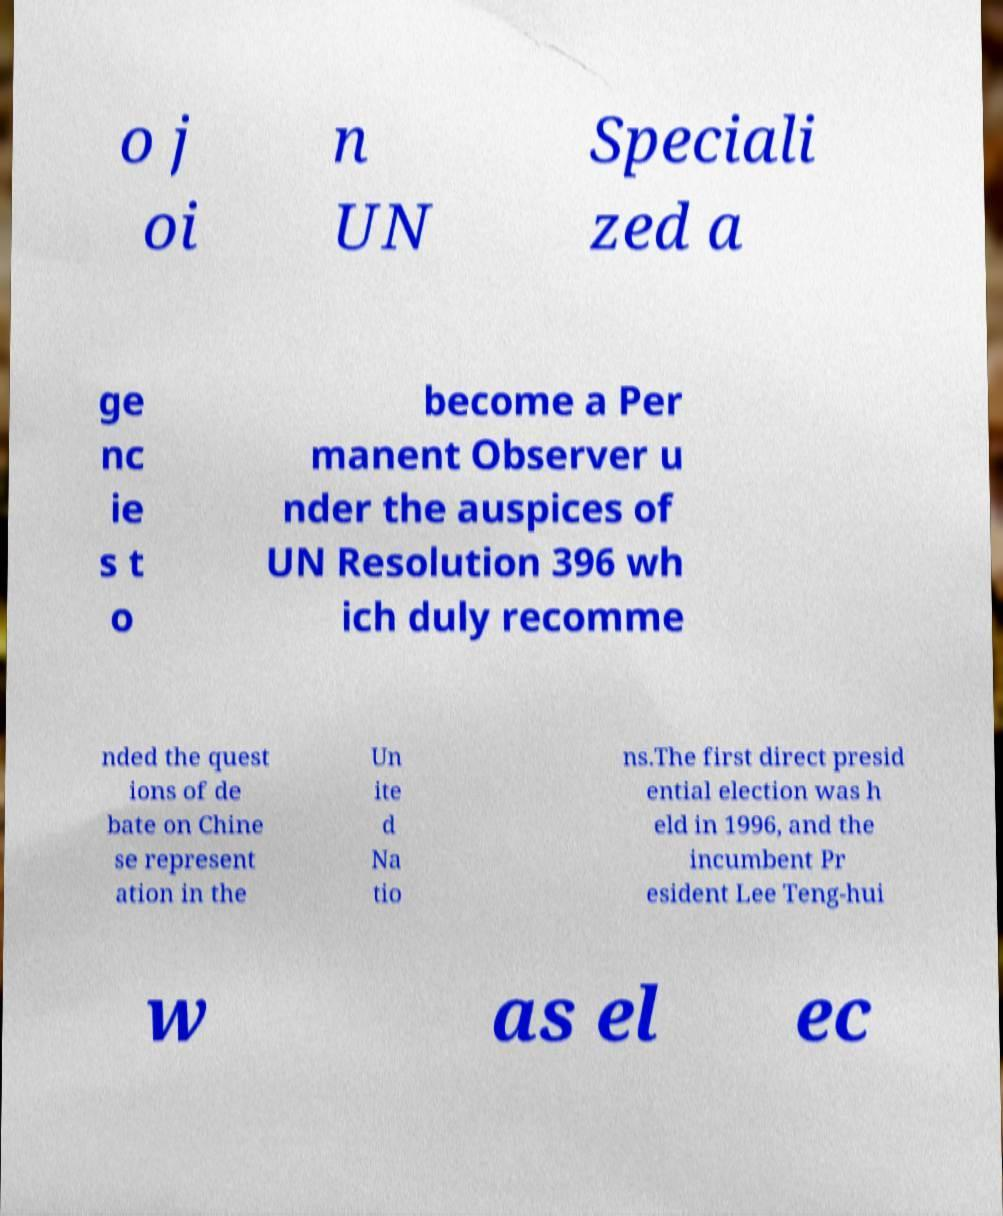Please identify and transcribe the text found in this image. o j oi n UN Speciali zed a ge nc ie s t o become a Per manent Observer u nder the auspices of UN Resolution 396 wh ich duly recomme nded the quest ions of de bate on Chine se represent ation in the Un ite d Na tio ns.The first direct presid ential election was h eld in 1996, and the incumbent Pr esident Lee Teng-hui w as el ec 